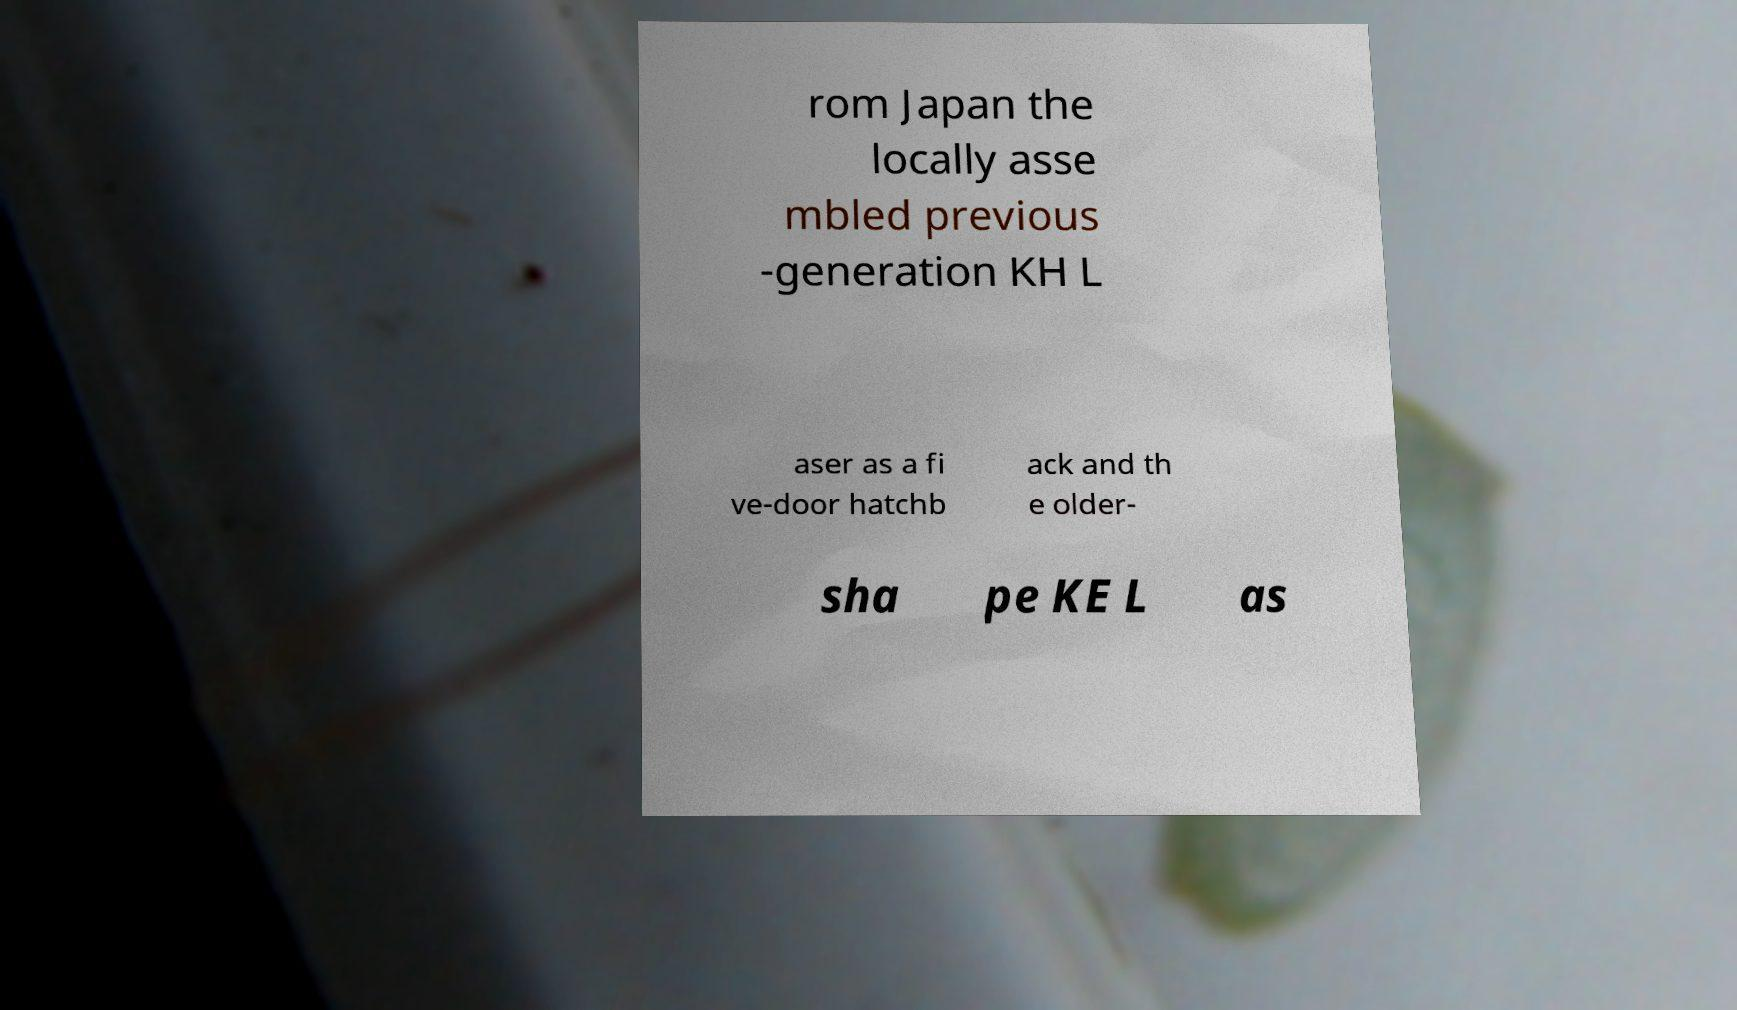Can you accurately transcribe the text from the provided image for me? rom Japan the locally asse mbled previous -generation KH L aser as a fi ve-door hatchb ack and th e older- sha pe KE L as 